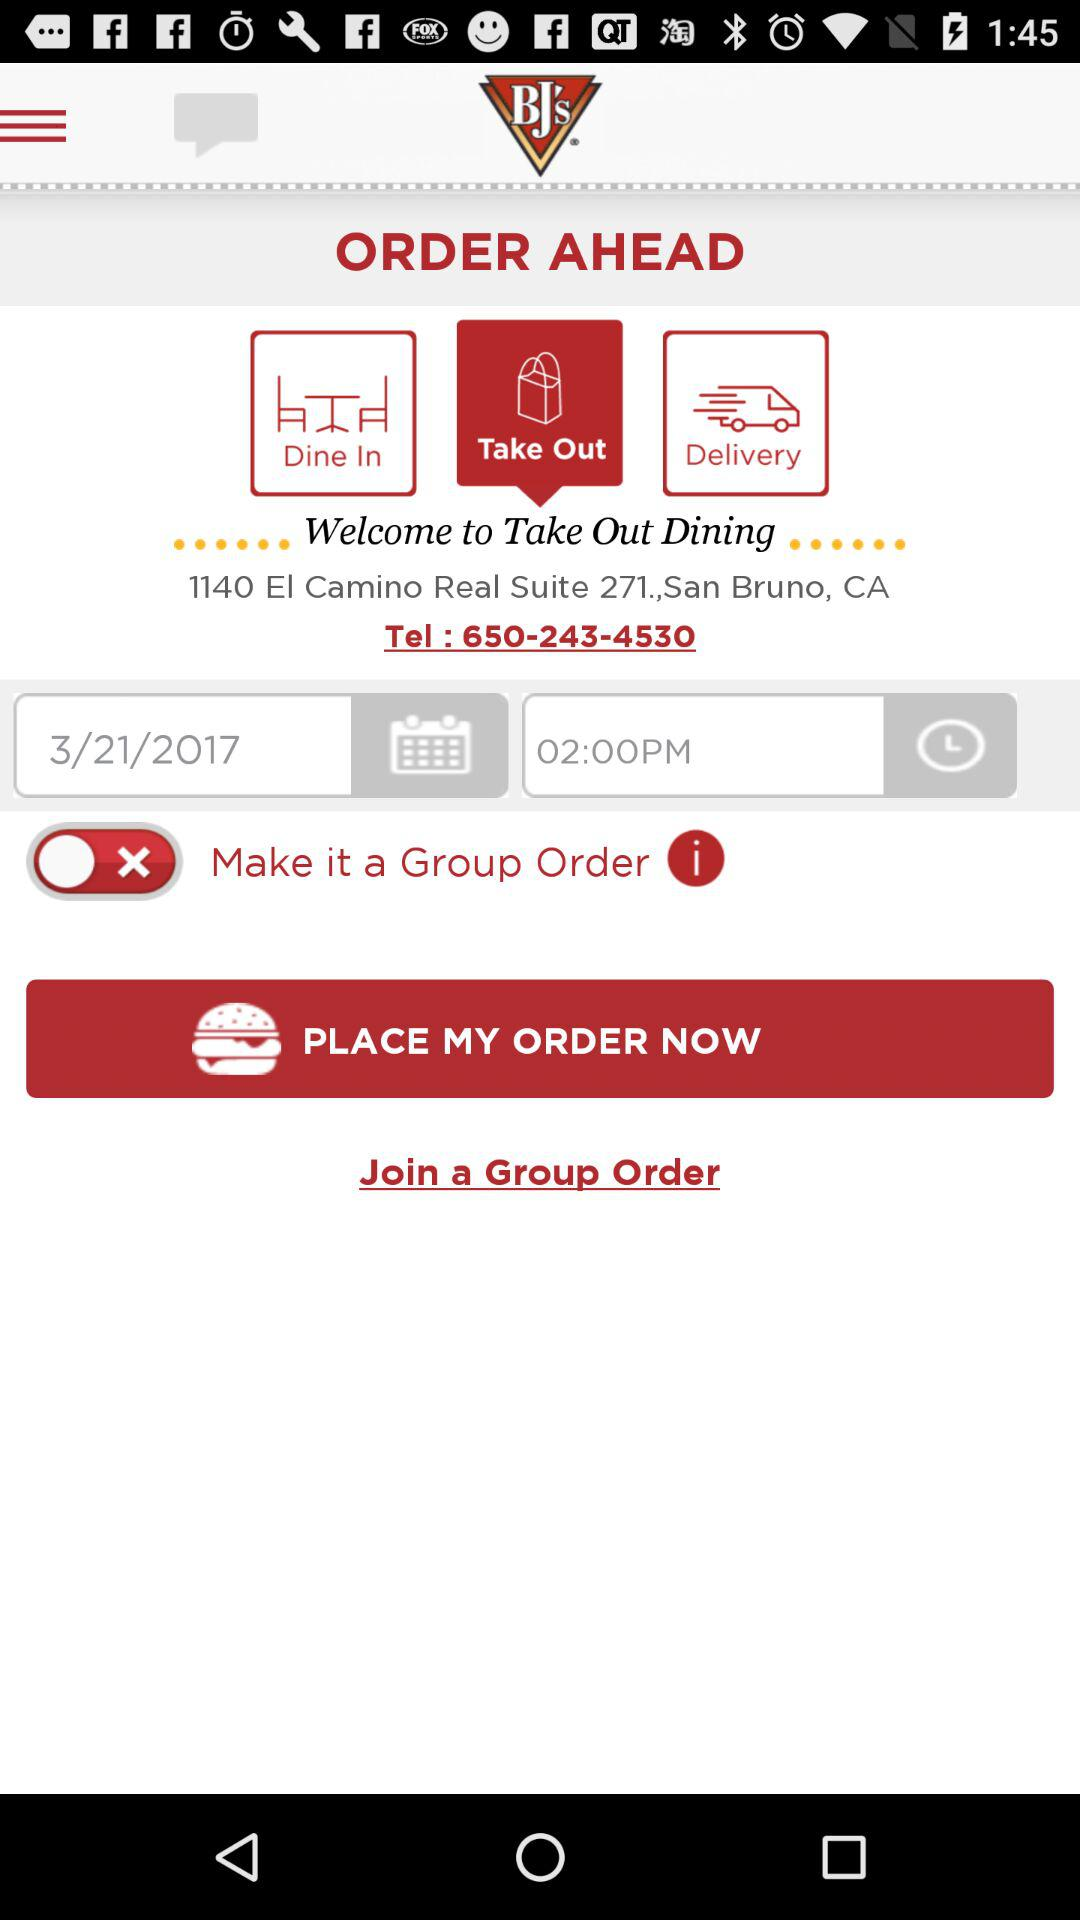How many rows of dots are there in the order form?
Answer the question using a single word or phrase. 2 